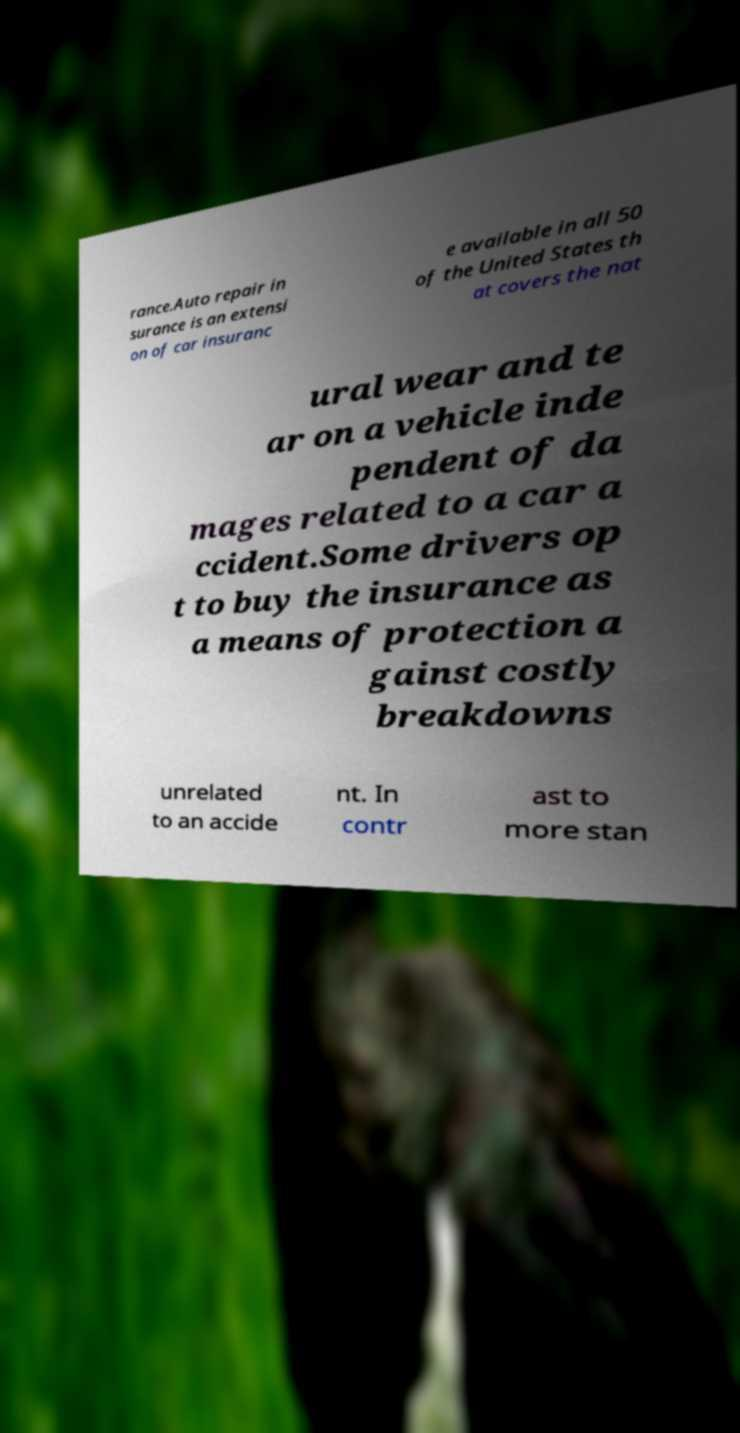What messages or text are displayed in this image? I need them in a readable, typed format. rance.Auto repair in surance is an extensi on of car insuranc e available in all 50 of the United States th at covers the nat ural wear and te ar on a vehicle inde pendent of da mages related to a car a ccident.Some drivers op t to buy the insurance as a means of protection a gainst costly breakdowns unrelated to an accide nt. In contr ast to more stan 